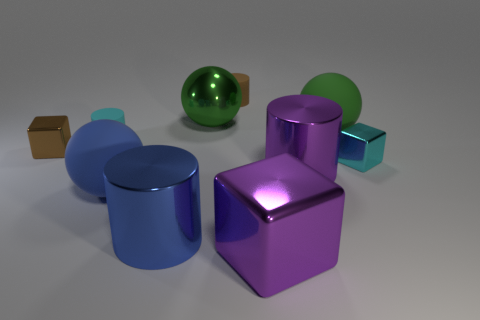Is the color of the tiny metal thing in front of the tiny brown cube the same as the rubber ball that is right of the large blue cylinder?
Your answer should be compact. No. Are there any blocks that have the same size as the cyan cylinder?
Your answer should be compact. Yes. There is a thing that is both right of the large purple cylinder and behind the tiny cyan block; what is its material?
Give a very brief answer. Rubber. How many metallic things are either cyan cylinders or large red cylinders?
Your response must be concise. 0. The blue thing that is made of the same material as the brown cylinder is what shape?
Offer a very short reply. Sphere. How many things are both behind the purple metal cylinder and right of the shiny sphere?
Provide a short and direct response. 3. Are there any other things that are the same shape as the tiny cyan shiny thing?
Ensure brevity in your answer.  Yes. There is a cyan object that is in front of the small cyan cylinder; what is its size?
Provide a short and direct response. Small. What number of other things are the same color as the big shiny sphere?
Your response must be concise. 1. What is the material of the small block left of the small matte object in front of the metal sphere?
Your answer should be very brief. Metal. 